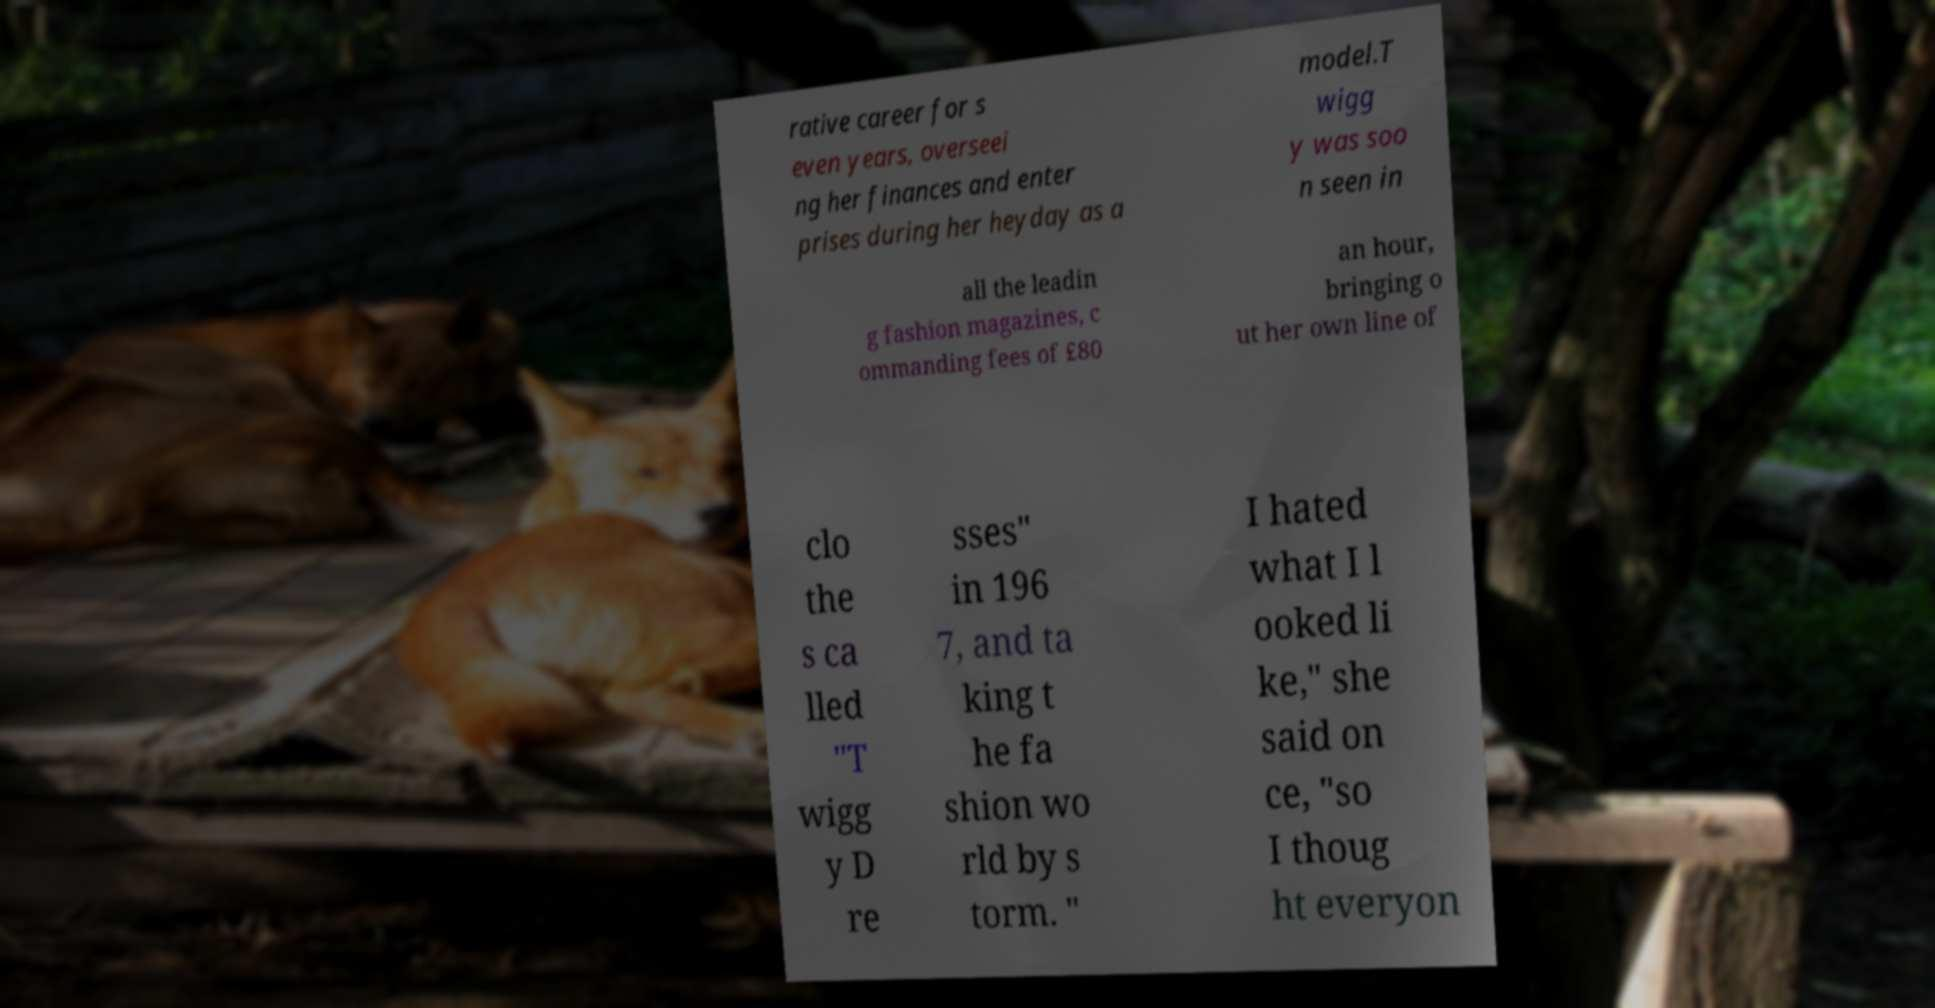What messages or text are displayed in this image? I need them in a readable, typed format. rative career for s even years, overseei ng her finances and enter prises during her heyday as a model.T wigg y was soo n seen in all the leadin g fashion magazines, c ommanding fees of £80 an hour, bringing o ut her own line of clo the s ca lled "T wigg y D re sses" in 196 7, and ta king t he fa shion wo rld by s torm. " I hated what I l ooked li ke," she said on ce, "so I thoug ht everyon 